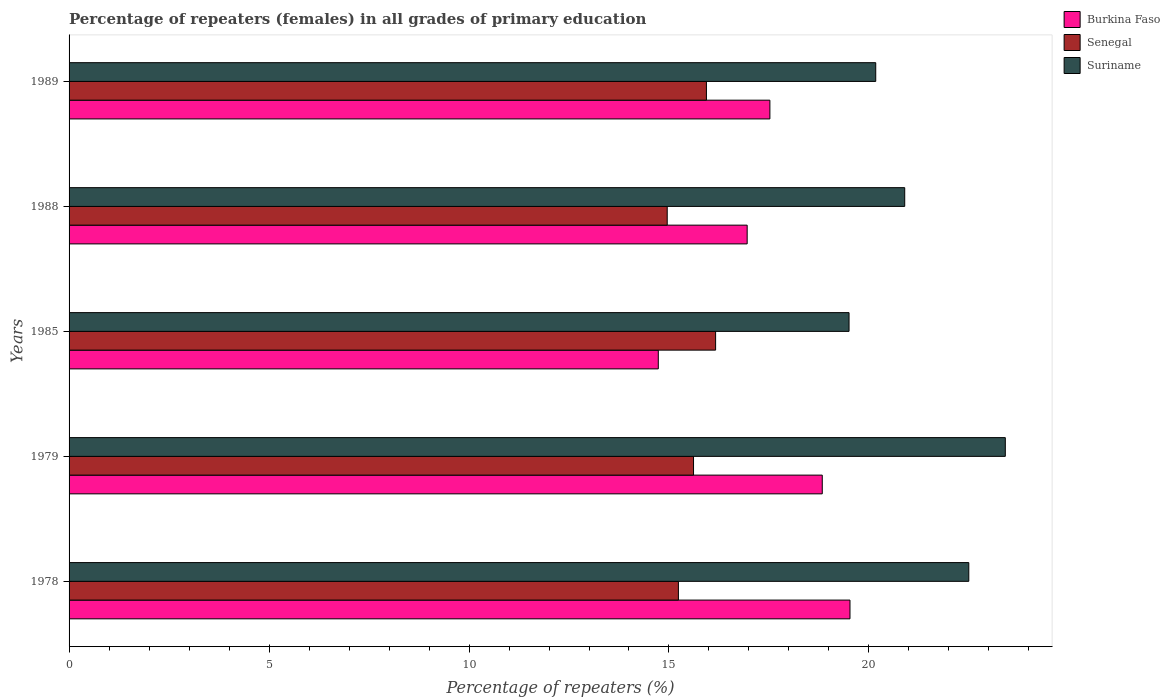How many different coloured bars are there?
Keep it short and to the point. 3. Are the number of bars on each tick of the Y-axis equal?
Your answer should be very brief. Yes. How many bars are there on the 2nd tick from the bottom?
Give a very brief answer. 3. What is the label of the 2nd group of bars from the top?
Your answer should be compact. 1988. In how many cases, is the number of bars for a given year not equal to the number of legend labels?
Make the answer very short. 0. What is the percentage of repeaters (females) in Senegal in 1988?
Ensure brevity in your answer.  14.96. Across all years, what is the maximum percentage of repeaters (females) in Senegal?
Give a very brief answer. 16.17. Across all years, what is the minimum percentage of repeaters (females) in Burkina Faso?
Give a very brief answer. 14.73. What is the total percentage of repeaters (females) in Senegal in the graph?
Provide a short and direct response. 77.91. What is the difference between the percentage of repeaters (females) in Senegal in 1988 and that in 1989?
Give a very brief answer. -0.98. What is the difference between the percentage of repeaters (females) in Burkina Faso in 1978 and the percentage of repeaters (females) in Suriname in 1988?
Your answer should be very brief. -1.37. What is the average percentage of repeaters (females) in Suriname per year?
Offer a terse response. 21.29. In the year 1989, what is the difference between the percentage of repeaters (females) in Suriname and percentage of repeaters (females) in Burkina Faso?
Provide a short and direct response. 2.65. What is the ratio of the percentage of repeaters (females) in Senegal in 1978 to that in 1988?
Provide a short and direct response. 1.02. Is the percentage of repeaters (females) in Senegal in 1979 less than that in 1988?
Give a very brief answer. No. Is the difference between the percentage of repeaters (females) in Suriname in 1979 and 1985 greater than the difference between the percentage of repeaters (females) in Burkina Faso in 1979 and 1985?
Give a very brief answer. No. What is the difference between the highest and the second highest percentage of repeaters (females) in Burkina Faso?
Make the answer very short. 0.69. What is the difference between the highest and the lowest percentage of repeaters (females) in Burkina Faso?
Your answer should be very brief. 4.79. In how many years, is the percentage of repeaters (females) in Burkina Faso greater than the average percentage of repeaters (females) in Burkina Faso taken over all years?
Provide a succinct answer. 3. What does the 1st bar from the top in 1979 represents?
Your answer should be very brief. Suriname. What does the 3rd bar from the bottom in 1979 represents?
Provide a succinct answer. Suriname. Is it the case that in every year, the sum of the percentage of repeaters (females) in Burkina Faso and percentage of repeaters (females) in Suriname is greater than the percentage of repeaters (females) in Senegal?
Offer a terse response. Yes. How many years are there in the graph?
Give a very brief answer. 5. What is the difference between two consecutive major ticks on the X-axis?
Provide a short and direct response. 5. Does the graph contain grids?
Keep it short and to the point. No. How are the legend labels stacked?
Ensure brevity in your answer.  Vertical. What is the title of the graph?
Give a very brief answer. Percentage of repeaters (females) in all grades of primary education. Does "Nigeria" appear as one of the legend labels in the graph?
Ensure brevity in your answer.  No. What is the label or title of the X-axis?
Give a very brief answer. Percentage of repeaters (%). What is the label or title of the Y-axis?
Provide a succinct answer. Years. What is the Percentage of repeaters (%) of Burkina Faso in 1978?
Provide a succinct answer. 19.53. What is the Percentage of repeaters (%) of Senegal in 1978?
Offer a terse response. 15.24. What is the Percentage of repeaters (%) of Suriname in 1978?
Offer a terse response. 22.5. What is the Percentage of repeaters (%) in Burkina Faso in 1979?
Keep it short and to the point. 18.83. What is the Percentage of repeaters (%) in Senegal in 1979?
Your answer should be compact. 15.61. What is the Percentage of repeaters (%) of Suriname in 1979?
Offer a very short reply. 23.41. What is the Percentage of repeaters (%) in Burkina Faso in 1985?
Provide a succinct answer. 14.73. What is the Percentage of repeaters (%) in Senegal in 1985?
Ensure brevity in your answer.  16.17. What is the Percentage of repeaters (%) in Suriname in 1985?
Ensure brevity in your answer.  19.5. What is the Percentage of repeaters (%) in Burkina Faso in 1988?
Your answer should be compact. 16.95. What is the Percentage of repeaters (%) in Senegal in 1988?
Provide a succinct answer. 14.96. What is the Percentage of repeaters (%) in Suriname in 1988?
Offer a very short reply. 20.89. What is the Percentage of repeaters (%) in Burkina Faso in 1989?
Offer a terse response. 17.52. What is the Percentage of repeaters (%) in Senegal in 1989?
Provide a succinct answer. 15.94. What is the Percentage of repeaters (%) in Suriname in 1989?
Provide a succinct answer. 20.17. Across all years, what is the maximum Percentage of repeaters (%) in Burkina Faso?
Your response must be concise. 19.53. Across all years, what is the maximum Percentage of repeaters (%) in Senegal?
Your response must be concise. 16.17. Across all years, what is the maximum Percentage of repeaters (%) in Suriname?
Provide a succinct answer. 23.41. Across all years, what is the minimum Percentage of repeaters (%) in Burkina Faso?
Your answer should be very brief. 14.73. Across all years, what is the minimum Percentage of repeaters (%) of Senegal?
Give a very brief answer. 14.96. Across all years, what is the minimum Percentage of repeaters (%) in Suriname?
Your answer should be very brief. 19.5. What is the total Percentage of repeaters (%) in Burkina Faso in the graph?
Provide a succinct answer. 87.57. What is the total Percentage of repeaters (%) of Senegal in the graph?
Provide a succinct answer. 77.91. What is the total Percentage of repeaters (%) in Suriname in the graph?
Make the answer very short. 106.47. What is the difference between the Percentage of repeaters (%) in Burkina Faso in 1978 and that in 1979?
Offer a terse response. 0.69. What is the difference between the Percentage of repeaters (%) of Senegal in 1978 and that in 1979?
Make the answer very short. -0.38. What is the difference between the Percentage of repeaters (%) in Suriname in 1978 and that in 1979?
Provide a short and direct response. -0.91. What is the difference between the Percentage of repeaters (%) in Burkina Faso in 1978 and that in 1985?
Your answer should be very brief. 4.79. What is the difference between the Percentage of repeaters (%) in Senegal in 1978 and that in 1985?
Provide a short and direct response. -0.93. What is the difference between the Percentage of repeaters (%) of Suriname in 1978 and that in 1985?
Offer a terse response. 2.99. What is the difference between the Percentage of repeaters (%) in Burkina Faso in 1978 and that in 1988?
Your answer should be very brief. 2.57. What is the difference between the Percentage of repeaters (%) of Senegal in 1978 and that in 1988?
Make the answer very short. 0.28. What is the difference between the Percentage of repeaters (%) of Suriname in 1978 and that in 1988?
Your answer should be compact. 1.6. What is the difference between the Percentage of repeaters (%) of Burkina Faso in 1978 and that in 1989?
Your answer should be very brief. 2. What is the difference between the Percentage of repeaters (%) of Senegal in 1978 and that in 1989?
Offer a terse response. -0.7. What is the difference between the Percentage of repeaters (%) in Suriname in 1978 and that in 1989?
Your response must be concise. 2.33. What is the difference between the Percentage of repeaters (%) in Burkina Faso in 1979 and that in 1985?
Keep it short and to the point. 4.1. What is the difference between the Percentage of repeaters (%) of Senegal in 1979 and that in 1985?
Your answer should be very brief. -0.55. What is the difference between the Percentage of repeaters (%) of Suriname in 1979 and that in 1985?
Give a very brief answer. 3.91. What is the difference between the Percentage of repeaters (%) of Burkina Faso in 1979 and that in 1988?
Provide a succinct answer. 1.88. What is the difference between the Percentage of repeaters (%) in Senegal in 1979 and that in 1988?
Provide a succinct answer. 0.66. What is the difference between the Percentage of repeaters (%) in Suriname in 1979 and that in 1988?
Provide a short and direct response. 2.52. What is the difference between the Percentage of repeaters (%) in Burkina Faso in 1979 and that in 1989?
Provide a succinct answer. 1.31. What is the difference between the Percentage of repeaters (%) in Senegal in 1979 and that in 1989?
Offer a terse response. -0.32. What is the difference between the Percentage of repeaters (%) in Suriname in 1979 and that in 1989?
Keep it short and to the point. 3.24. What is the difference between the Percentage of repeaters (%) of Burkina Faso in 1985 and that in 1988?
Provide a succinct answer. -2.22. What is the difference between the Percentage of repeaters (%) in Senegal in 1985 and that in 1988?
Make the answer very short. 1.21. What is the difference between the Percentage of repeaters (%) of Suriname in 1985 and that in 1988?
Keep it short and to the point. -1.39. What is the difference between the Percentage of repeaters (%) in Burkina Faso in 1985 and that in 1989?
Your answer should be very brief. -2.79. What is the difference between the Percentage of repeaters (%) in Senegal in 1985 and that in 1989?
Offer a terse response. 0.23. What is the difference between the Percentage of repeaters (%) in Suriname in 1985 and that in 1989?
Give a very brief answer. -0.67. What is the difference between the Percentage of repeaters (%) in Burkina Faso in 1988 and that in 1989?
Provide a short and direct response. -0.57. What is the difference between the Percentage of repeaters (%) in Senegal in 1988 and that in 1989?
Keep it short and to the point. -0.98. What is the difference between the Percentage of repeaters (%) of Suriname in 1988 and that in 1989?
Keep it short and to the point. 0.72. What is the difference between the Percentage of repeaters (%) in Burkina Faso in 1978 and the Percentage of repeaters (%) in Senegal in 1979?
Keep it short and to the point. 3.91. What is the difference between the Percentage of repeaters (%) of Burkina Faso in 1978 and the Percentage of repeaters (%) of Suriname in 1979?
Provide a short and direct response. -3.88. What is the difference between the Percentage of repeaters (%) of Senegal in 1978 and the Percentage of repeaters (%) of Suriname in 1979?
Provide a short and direct response. -8.17. What is the difference between the Percentage of repeaters (%) in Burkina Faso in 1978 and the Percentage of repeaters (%) in Senegal in 1985?
Your response must be concise. 3.36. What is the difference between the Percentage of repeaters (%) of Burkina Faso in 1978 and the Percentage of repeaters (%) of Suriname in 1985?
Ensure brevity in your answer.  0.02. What is the difference between the Percentage of repeaters (%) of Senegal in 1978 and the Percentage of repeaters (%) of Suriname in 1985?
Your answer should be very brief. -4.27. What is the difference between the Percentage of repeaters (%) in Burkina Faso in 1978 and the Percentage of repeaters (%) in Senegal in 1988?
Your answer should be very brief. 4.57. What is the difference between the Percentage of repeaters (%) in Burkina Faso in 1978 and the Percentage of repeaters (%) in Suriname in 1988?
Your answer should be compact. -1.37. What is the difference between the Percentage of repeaters (%) of Senegal in 1978 and the Percentage of repeaters (%) of Suriname in 1988?
Provide a succinct answer. -5.66. What is the difference between the Percentage of repeaters (%) of Burkina Faso in 1978 and the Percentage of repeaters (%) of Senegal in 1989?
Provide a succinct answer. 3.59. What is the difference between the Percentage of repeaters (%) in Burkina Faso in 1978 and the Percentage of repeaters (%) in Suriname in 1989?
Offer a terse response. -0.64. What is the difference between the Percentage of repeaters (%) in Senegal in 1978 and the Percentage of repeaters (%) in Suriname in 1989?
Offer a very short reply. -4.93. What is the difference between the Percentage of repeaters (%) of Burkina Faso in 1979 and the Percentage of repeaters (%) of Senegal in 1985?
Offer a very short reply. 2.67. What is the difference between the Percentage of repeaters (%) of Burkina Faso in 1979 and the Percentage of repeaters (%) of Suriname in 1985?
Provide a succinct answer. -0.67. What is the difference between the Percentage of repeaters (%) of Senegal in 1979 and the Percentage of repeaters (%) of Suriname in 1985?
Your response must be concise. -3.89. What is the difference between the Percentage of repeaters (%) of Burkina Faso in 1979 and the Percentage of repeaters (%) of Senegal in 1988?
Give a very brief answer. 3.88. What is the difference between the Percentage of repeaters (%) of Burkina Faso in 1979 and the Percentage of repeaters (%) of Suriname in 1988?
Give a very brief answer. -2.06. What is the difference between the Percentage of repeaters (%) of Senegal in 1979 and the Percentage of repeaters (%) of Suriname in 1988?
Provide a short and direct response. -5.28. What is the difference between the Percentage of repeaters (%) of Burkina Faso in 1979 and the Percentage of repeaters (%) of Senegal in 1989?
Offer a very short reply. 2.9. What is the difference between the Percentage of repeaters (%) of Burkina Faso in 1979 and the Percentage of repeaters (%) of Suriname in 1989?
Your answer should be very brief. -1.34. What is the difference between the Percentage of repeaters (%) in Senegal in 1979 and the Percentage of repeaters (%) in Suriname in 1989?
Make the answer very short. -4.56. What is the difference between the Percentage of repeaters (%) in Burkina Faso in 1985 and the Percentage of repeaters (%) in Senegal in 1988?
Offer a very short reply. -0.22. What is the difference between the Percentage of repeaters (%) in Burkina Faso in 1985 and the Percentage of repeaters (%) in Suriname in 1988?
Your response must be concise. -6.16. What is the difference between the Percentage of repeaters (%) in Senegal in 1985 and the Percentage of repeaters (%) in Suriname in 1988?
Your response must be concise. -4.73. What is the difference between the Percentage of repeaters (%) in Burkina Faso in 1985 and the Percentage of repeaters (%) in Senegal in 1989?
Keep it short and to the point. -1.2. What is the difference between the Percentage of repeaters (%) of Burkina Faso in 1985 and the Percentage of repeaters (%) of Suriname in 1989?
Your answer should be very brief. -5.44. What is the difference between the Percentage of repeaters (%) of Senegal in 1985 and the Percentage of repeaters (%) of Suriname in 1989?
Give a very brief answer. -4. What is the difference between the Percentage of repeaters (%) in Burkina Faso in 1988 and the Percentage of repeaters (%) in Suriname in 1989?
Make the answer very short. -3.21. What is the difference between the Percentage of repeaters (%) in Senegal in 1988 and the Percentage of repeaters (%) in Suriname in 1989?
Your answer should be very brief. -5.21. What is the average Percentage of repeaters (%) of Burkina Faso per year?
Provide a short and direct response. 17.51. What is the average Percentage of repeaters (%) in Senegal per year?
Your response must be concise. 15.58. What is the average Percentage of repeaters (%) of Suriname per year?
Make the answer very short. 21.29. In the year 1978, what is the difference between the Percentage of repeaters (%) of Burkina Faso and Percentage of repeaters (%) of Senegal?
Give a very brief answer. 4.29. In the year 1978, what is the difference between the Percentage of repeaters (%) of Burkina Faso and Percentage of repeaters (%) of Suriname?
Give a very brief answer. -2.97. In the year 1978, what is the difference between the Percentage of repeaters (%) in Senegal and Percentage of repeaters (%) in Suriname?
Provide a succinct answer. -7.26. In the year 1979, what is the difference between the Percentage of repeaters (%) in Burkina Faso and Percentage of repeaters (%) in Senegal?
Your answer should be compact. 3.22. In the year 1979, what is the difference between the Percentage of repeaters (%) in Burkina Faso and Percentage of repeaters (%) in Suriname?
Provide a short and direct response. -4.58. In the year 1979, what is the difference between the Percentage of repeaters (%) of Senegal and Percentage of repeaters (%) of Suriname?
Your answer should be compact. -7.8. In the year 1985, what is the difference between the Percentage of repeaters (%) in Burkina Faso and Percentage of repeaters (%) in Senegal?
Offer a terse response. -1.43. In the year 1985, what is the difference between the Percentage of repeaters (%) of Burkina Faso and Percentage of repeaters (%) of Suriname?
Your answer should be compact. -4.77. In the year 1985, what is the difference between the Percentage of repeaters (%) of Senegal and Percentage of repeaters (%) of Suriname?
Make the answer very short. -3.34. In the year 1988, what is the difference between the Percentage of repeaters (%) of Burkina Faso and Percentage of repeaters (%) of Senegal?
Provide a short and direct response. 2. In the year 1988, what is the difference between the Percentage of repeaters (%) in Burkina Faso and Percentage of repeaters (%) in Suriname?
Provide a short and direct response. -3.94. In the year 1988, what is the difference between the Percentage of repeaters (%) of Senegal and Percentage of repeaters (%) of Suriname?
Your answer should be very brief. -5.94. In the year 1989, what is the difference between the Percentage of repeaters (%) in Burkina Faso and Percentage of repeaters (%) in Senegal?
Ensure brevity in your answer.  1.59. In the year 1989, what is the difference between the Percentage of repeaters (%) in Burkina Faso and Percentage of repeaters (%) in Suriname?
Offer a very short reply. -2.65. In the year 1989, what is the difference between the Percentage of repeaters (%) of Senegal and Percentage of repeaters (%) of Suriname?
Offer a very short reply. -4.23. What is the ratio of the Percentage of repeaters (%) in Burkina Faso in 1978 to that in 1979?
Make the answer very short. 1.04. What is the ratio of the Percentage of repeaters (%) of Senegal in 1978 to that in 1979?
Provide a succinct answer. 0.98. What is the ratio of the Percentage of repeaters (%) in Suriname in 1978 to that in 1979?
Your answer should be compact. 0.96. What is the ratio of the Percentage of repeaters (%) in Burkina Faso in 1978 to that in 1985?
Provide a succinct answer. 1.33. What is the ratio of the Percentage of repeaters (%) of Senegal in 1978 to that in 1985?
Offer a terse response. 0.94. What is the ratio of the Percentage of repeaters (%) in Suriname in 1978 to that in 1985?
Your answer should be very brief. 1.15. What is the ratio of the Percentage of repeaters (%) in Burkina Faso in 1978 to that in 1988?
Make the answer very short. 1.15. What is the ratio of the Percentage of repeaters (%) in Senegal in 1978 to that in 1988?
Give a very brief answer. 1.02. What is the ratio of the Percentage of repeaters (%) in Suriname in 1978 to that in 1988?
Give a very brief answer. 1.08. What is the ratio of the Percentage of repeaters (%) in Burkina Faso in 1978 to that in 1989?
Ensure brevity in your answer.  1.11. What is the ratio of the Percentage of repeaters (%) of Senegal in 1978 to that in 1989?
Offer a terse response. 0.96. What is the ratio of the Percentage of repeaters (%) of Suriname in 1978 to that in 1989?
Your response must be concise. 1.12. What is the ratio of the Percentage of repeaters (%) of Burkina Faso in 1979 to that in 1985?
Offer a very short reply. 1.28. What is the ratio of the Percentage of repeaters (%) in Senegal in 1979 to that in 1985?
Your response must be concise. 0.97. What is the ratio of the Percentage of repeaters (%) of Suriname in 1979 to that in 1985?
Your response must be concise. 1.2. What is the ratio of the Percentage of repeaters (%) of Burkina Faso in 1979 to that in 1988?
Make the answer very short. 1.11. What is the ratio of the Percentage of repeaters (%) of Senegal in 1979 to that in 1988?
Provide a succinct answer. 1.04. What is the ratio of the Percentage of repeaters (%) in Suriname in 1979 to that in 1988?
Your answer should be compact. 1.12. What is the ratio of the Percentage of repeaters (%) in Burkina Faso in 1979 to that in 1989?
Provide a short and direct response. 1.07. What is the ratio of the Percentage of repeaters (%) in Senegal in 1979 to that in 1989?
Offer a terse response. 0.98. What is the ratio of the Percentage of repeaters (%) in Suriname in 1979 to that in 1989?
Keep it short and to the point. 1.16. What is the ratio of the Percentage of repeaters (%) in Burkina Faso in 1985 to that in 1988?
Your answer should be compact. 0.87. What is the ratio of the Percentage of repeaters (%) in Senegal in 1985 to that in 1988?
Ensure brevity in your answer.  1.08. What is the ratio of the Percentage of repeaters (%) of Suriname in 1985 to that in 1988?
Make the answer very short. 0.93. What is the ratio of the Percentage of repeaters (%) in Burkina Faso in 1985 to that in 1989?
Your answer should be very brief. 0.84. What is the ratio of the Percentage of repeaters (%) of Senegal in 1985 to that in 1989?
Offer a very short reply. 1.01. What is the ratio of the Percentage of repeaters (%) of Suriname in 1985 to that in 1989?
Offer a very short reply. 0.97. What is the ratio of the Percentage of repeaters (%) in Burkina Faso in 1988 to that in 1989?
Provide a short and direct response. 0.97. What is the ratio of the Percentage of repeaters (%) of Senegal in 1988 to that in 1989?
Your response must be concise. 0.94. What is the ratio of the Percentage of repeaters (%) of Suriname in 1988 to that in 1989?
Provide a short and direct response. 1.04. What is the difference between the highest and the second highest Percentage of repeaters (%) of Burkina Faso?
Offer a very short reply. 0.69. What is the difference between the highest and the second highest Percentage of repeaters (%) of Senegal?
Your answer should be compact. 0.23. What is the difference between the highest and the second highest Percentage of repeaters (%) in Suriname?
Make the answer very short. 0.91. What is the difference between the highest and the lowest Percentage of repeaters (%) of Burkina Faso?
Your answer should be compact. 4.79. What is the difference between the highest and the lowest Percentage of repeaters (%) of Senegal?
Your answer should be very brief. 1.21. What is the difference between the highest and the lowest Percentage of repeaters (%) in Suriname?
Provide a short and direct response. 3.91. 